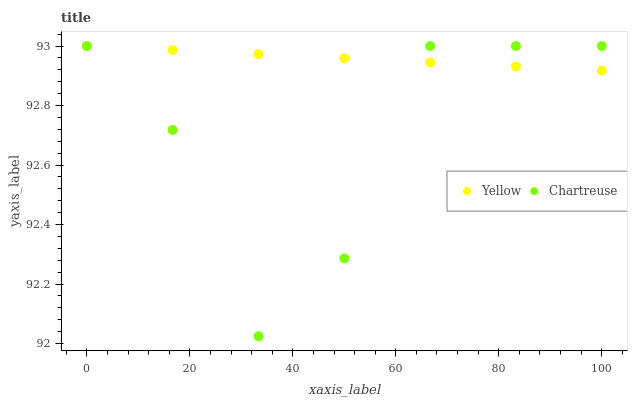Does Chartreuse have the minimum area under the curve?
Answer yes or no. Yes. Does Yellow have the maximum area under the curve?
Answer yes or no. Yes. Does Yellow have the minimum area under the curve?
Answer yes or no. No. Is Yellow the smoothest?
Answer yes or no. Yes. Is Chartreuse the roughest?
Answer yes or no. Yes. Is Yellow the roughest?
Answer yes or no. No. Does Chartreuse have the lowest value?
Answer yes or no. Yes. Does Yellow have the lowest value?
Answer yes or no. No. Does Yellow have the highest value?
Answer yes or no. Yes. Does Chartreuse intersect Yellow?
Answer yes or no. Yes. Is Chartreuse less than Yellow?
Answer yes or no. No. Is Chartreuse greater than Yellow?
Answer yes or no. No. 